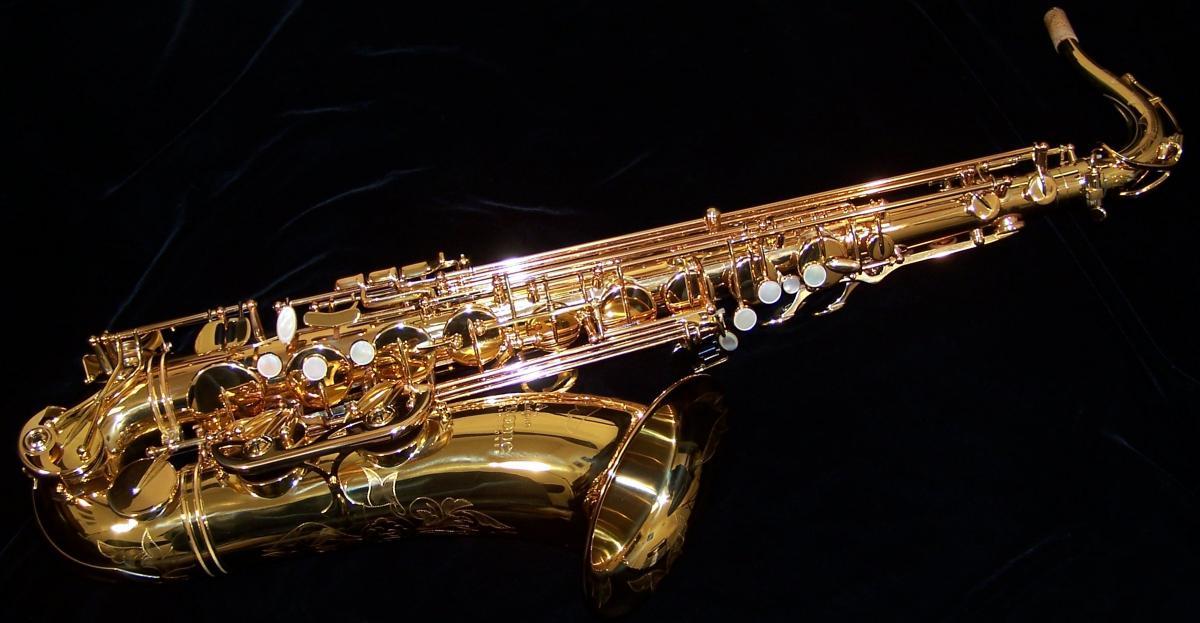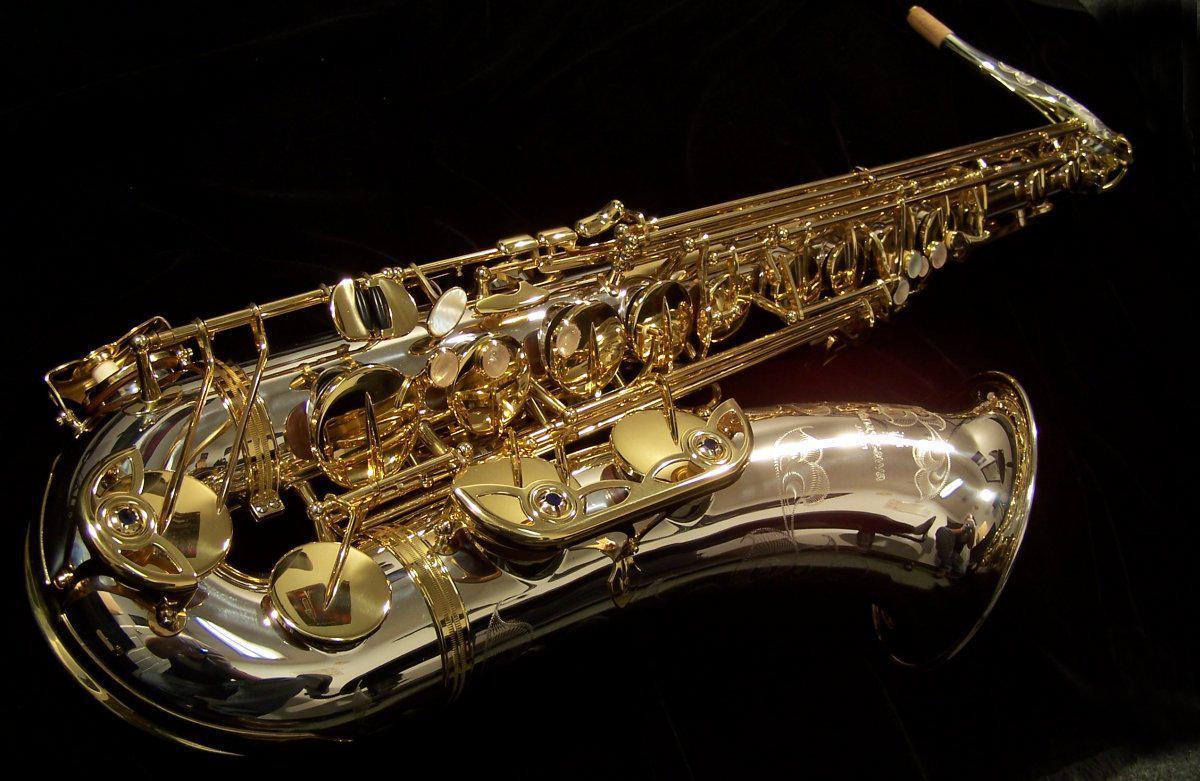The first image is the image on the left, the second image is the image on the right. Examine the images to the left and right. Is the description "No image shows a saxophone that is tilted at greater than a 45 degree angle from vertical." accurate? Answer yes or no. No. The first image is the image on the left, the second image is the image on the right. Evaluate the accuracy of this statement regarding the images: "all instruments are fully upright". Is it true? Answer yes or no. No. 